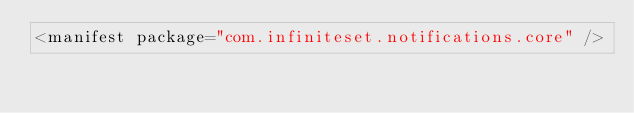Convert code to text. <code><loc_0><loc_0><loc_500><loc_500><_XML_><manifest package="com.infiniteset.notifications.core" />
</code> 